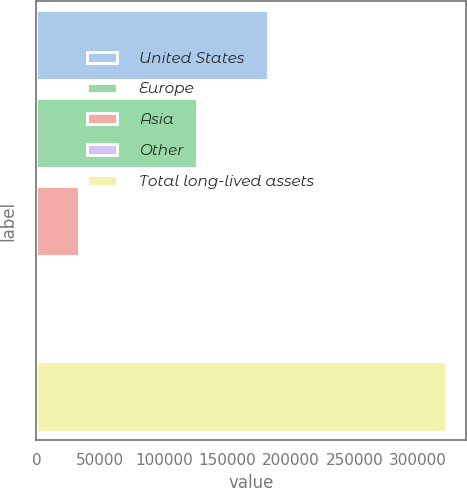<chart> <loc_0><loc_0><loc_500><loc_500><bar_chart><fcel>United States<fcel>Europe<fcel>Asia<fcel>Other<fcel>Total long-lived assets<nl><fcel>181851<fcel>126080<fcel>33270.7<fcel>1236<fcel>321583<nl></chart> 